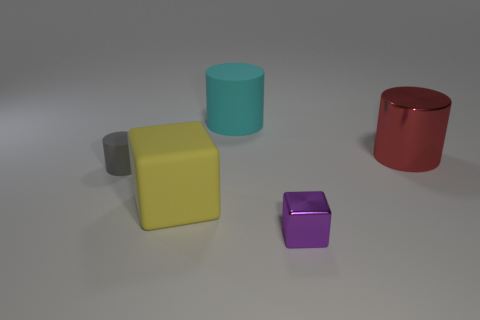Add 5 small rubber cylinders. How many objects exist? 10 Subtract all cubes. How many objects are left? 3 Subtract all purple metallic blocks. Subtract all large cyan matte cylinders. How many objects are left? 3 Add 4 big matte blocks. How many big matte blocks are left? 5 Add 4 large red shiny objects. How many large red shiny objects exist? 5 Subtract 0 gray spheres. How many objects are left? 5 